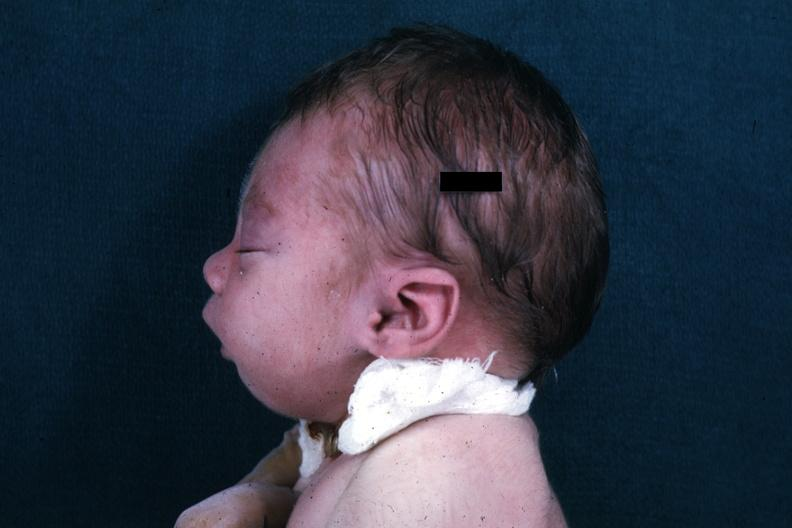what does this image show?
Answer the question using a single word or phrase. Lateral view of infants head showing mandibular lesion 